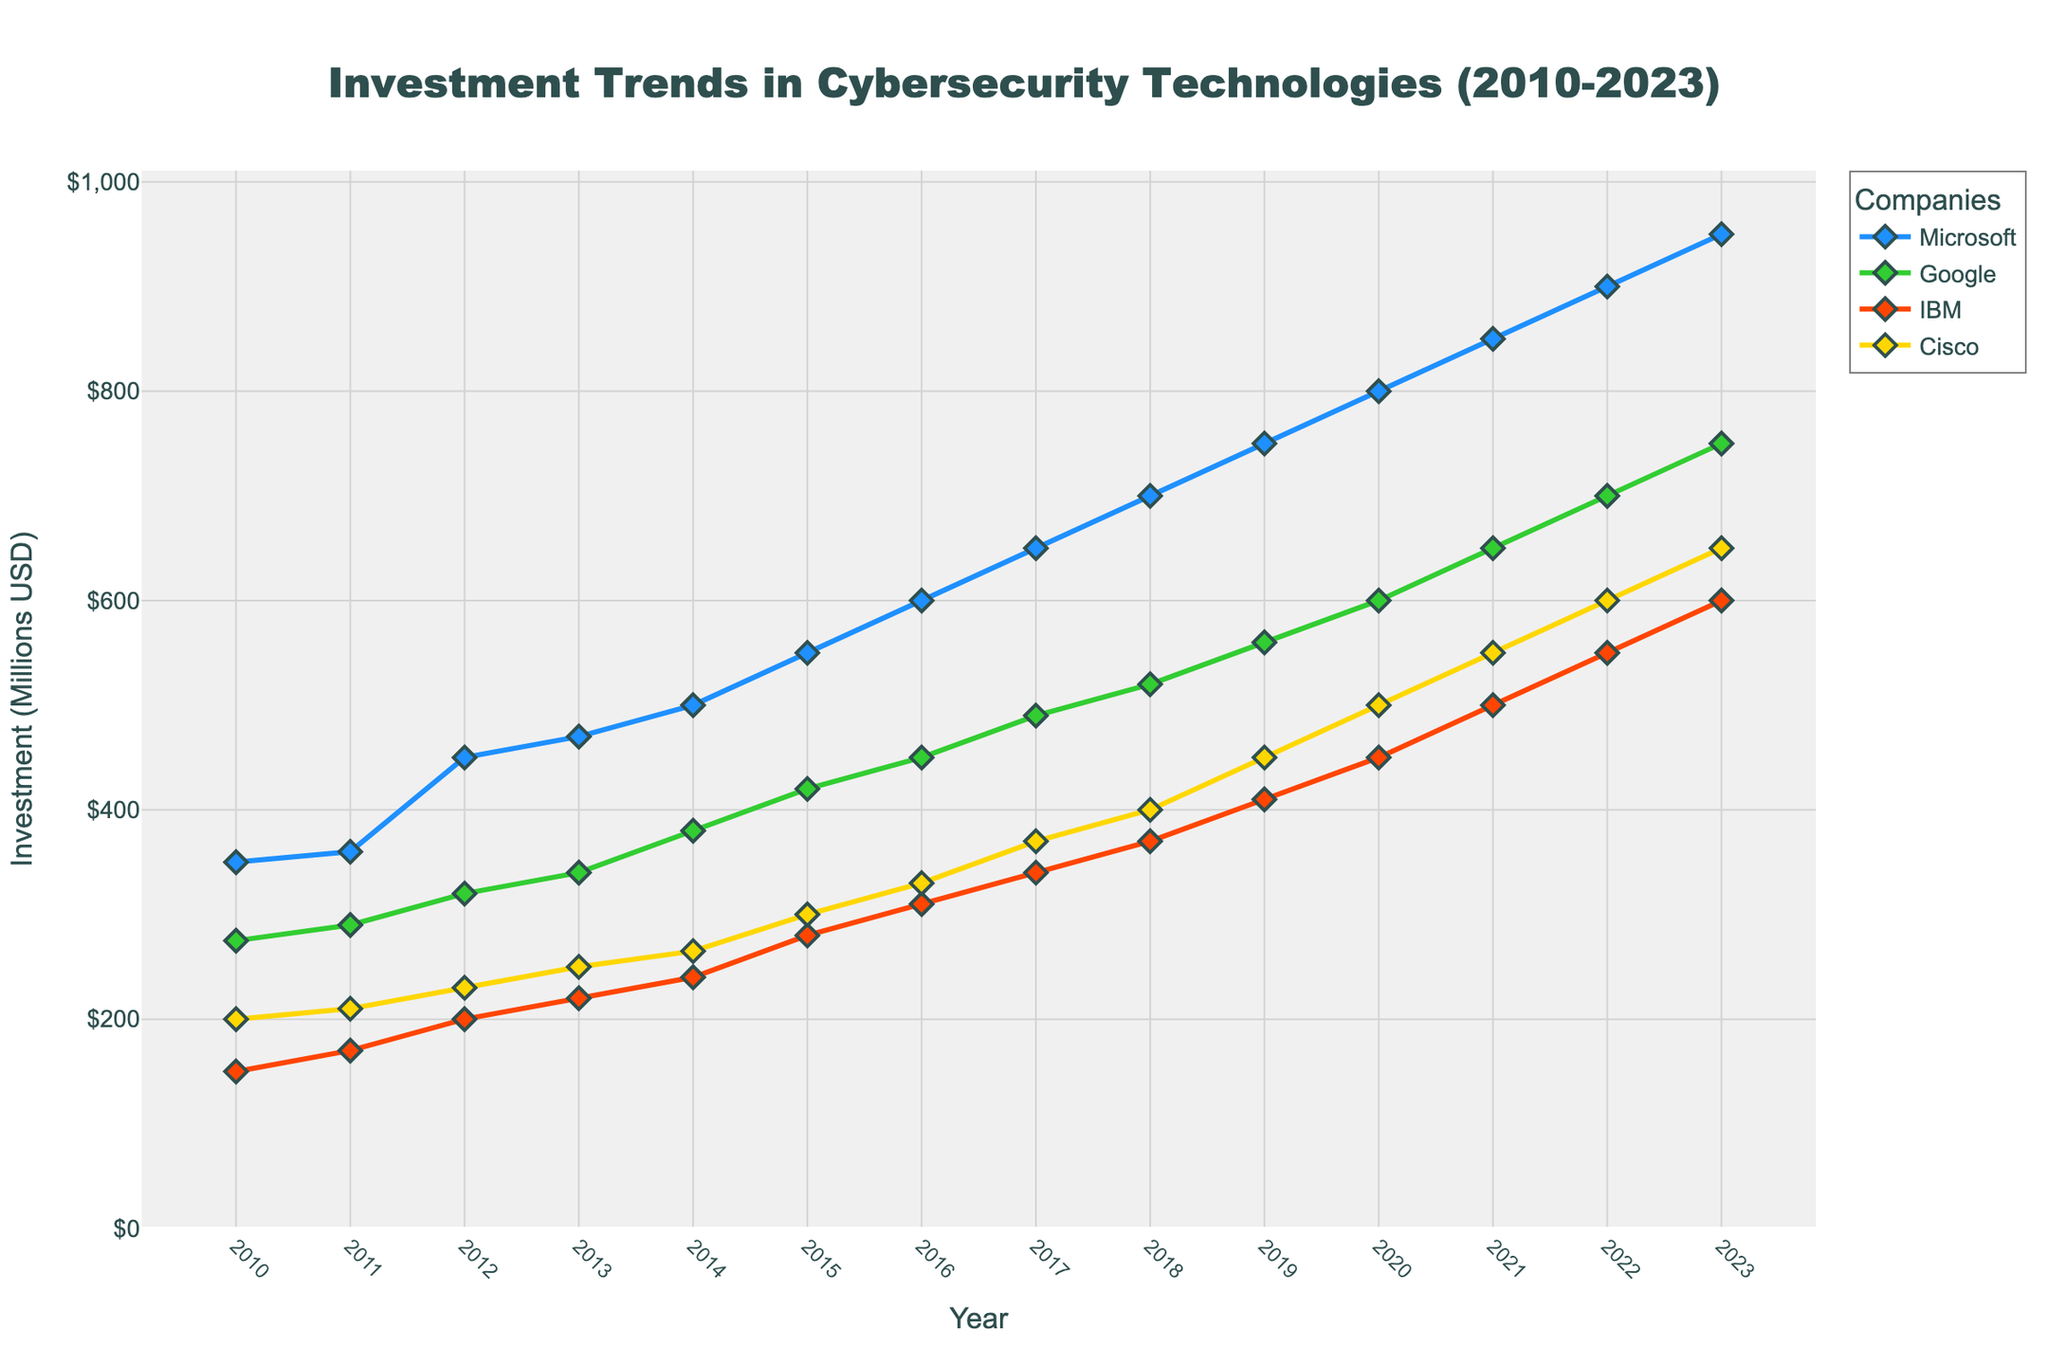What is the title of the plot? The title is located at the top center of the plot and is a clear descriptive text summarizing the content of the figure.
Answer: Investment Trends in Cybersecurity Technologies (2010-2023) Which company showed the highest investment in 2023? By examining the 2023 data points on the plot, the highest investment is indicated by the highest point among all companies.
Answer: Microsoft How has Google's investment in cybersecurity changed from 2010 to 2020? Compare Google's investment values from the beginning (2010) and the end (2020) of the period. Google’s investment increased from $275 million in 2010 to $600 million in 2020.
Answer: Increased by $325 million Which company has had the most consistent year-over-year increase in cybersecurity investment? Review the trend lines for all companies; the most consistent line in terms of yearly increments can be identified as the one with the least variations. Microsoft's line shows a steady upward trend.
Answer: Microsoft How many companies' investments exceeded $500 million in 2021? Check the 2021 data points to see which companies' investment values are above $500 million. Microsoft, Google, and Cisco exceed $500 million in 2021.
Answer: 3 What is the difference in cybersecurity investment between Microsoft and IBM in 2015? Locate the 2015 data points for Microsoft and IBM, then subtract IBM’s value from Microsoft’s value: $550 million - $280 million = $270 million.
Answer: $270 million Between which two consecutive years did Cisco see the highest increase in investment? Calculate the yearly differences for Cisco and identify the highest increase. The biggest jump is between 2020 and 2021: $550 million - $500 million = $50 million.
Answer: 2020 to 2021 In which year did IBM cross a $400 million investment in cybersecurity? Trace IBM's investment trend line and find the first year where the investment equals or exceeds $400 million. It occurs in 2019.
Answer: 2019 Did Google’s investment in cybersecurity ever surpass Microsoft’s during 2010-2023? Compare the trend lines of Google and Microsoft over the years. Google's line remains below Microsoft's throughout the period.
Answer: No Which year did all four companies invest at least $250 million in cybersecurity? Look for the year where each company's investment is equal to or above $250 million. In 2013, all companies meet this criterion.
Answer: 2013 